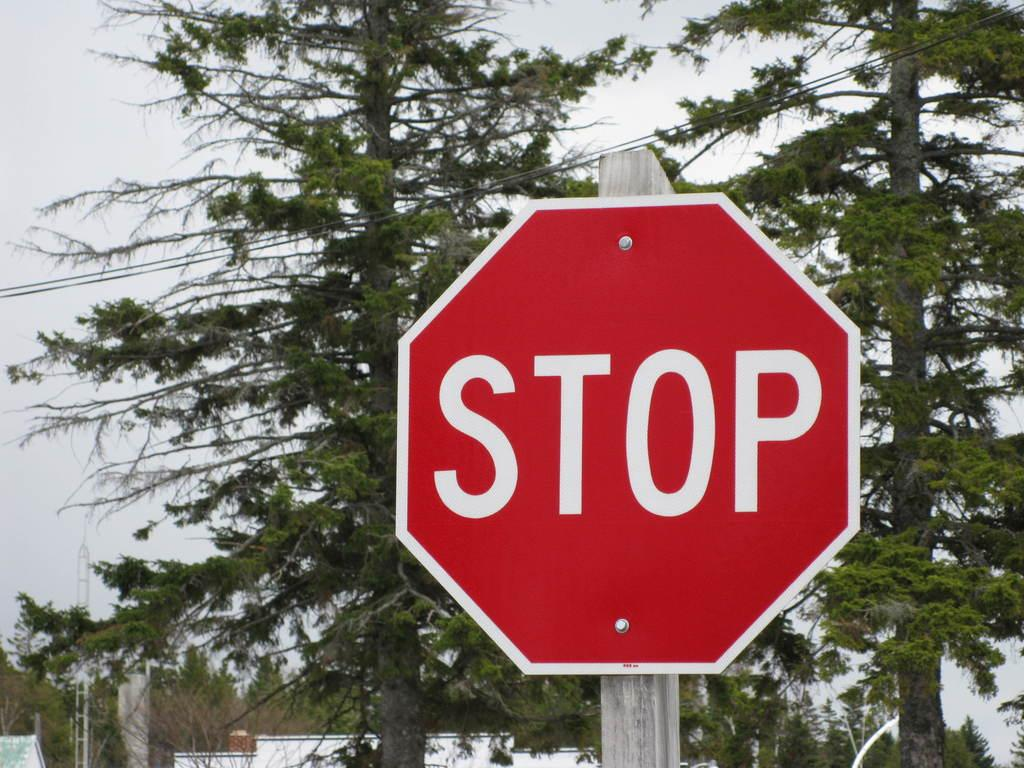Provide a one-sentence caption for the provided image. A stop sign is shown with trees in the background. 